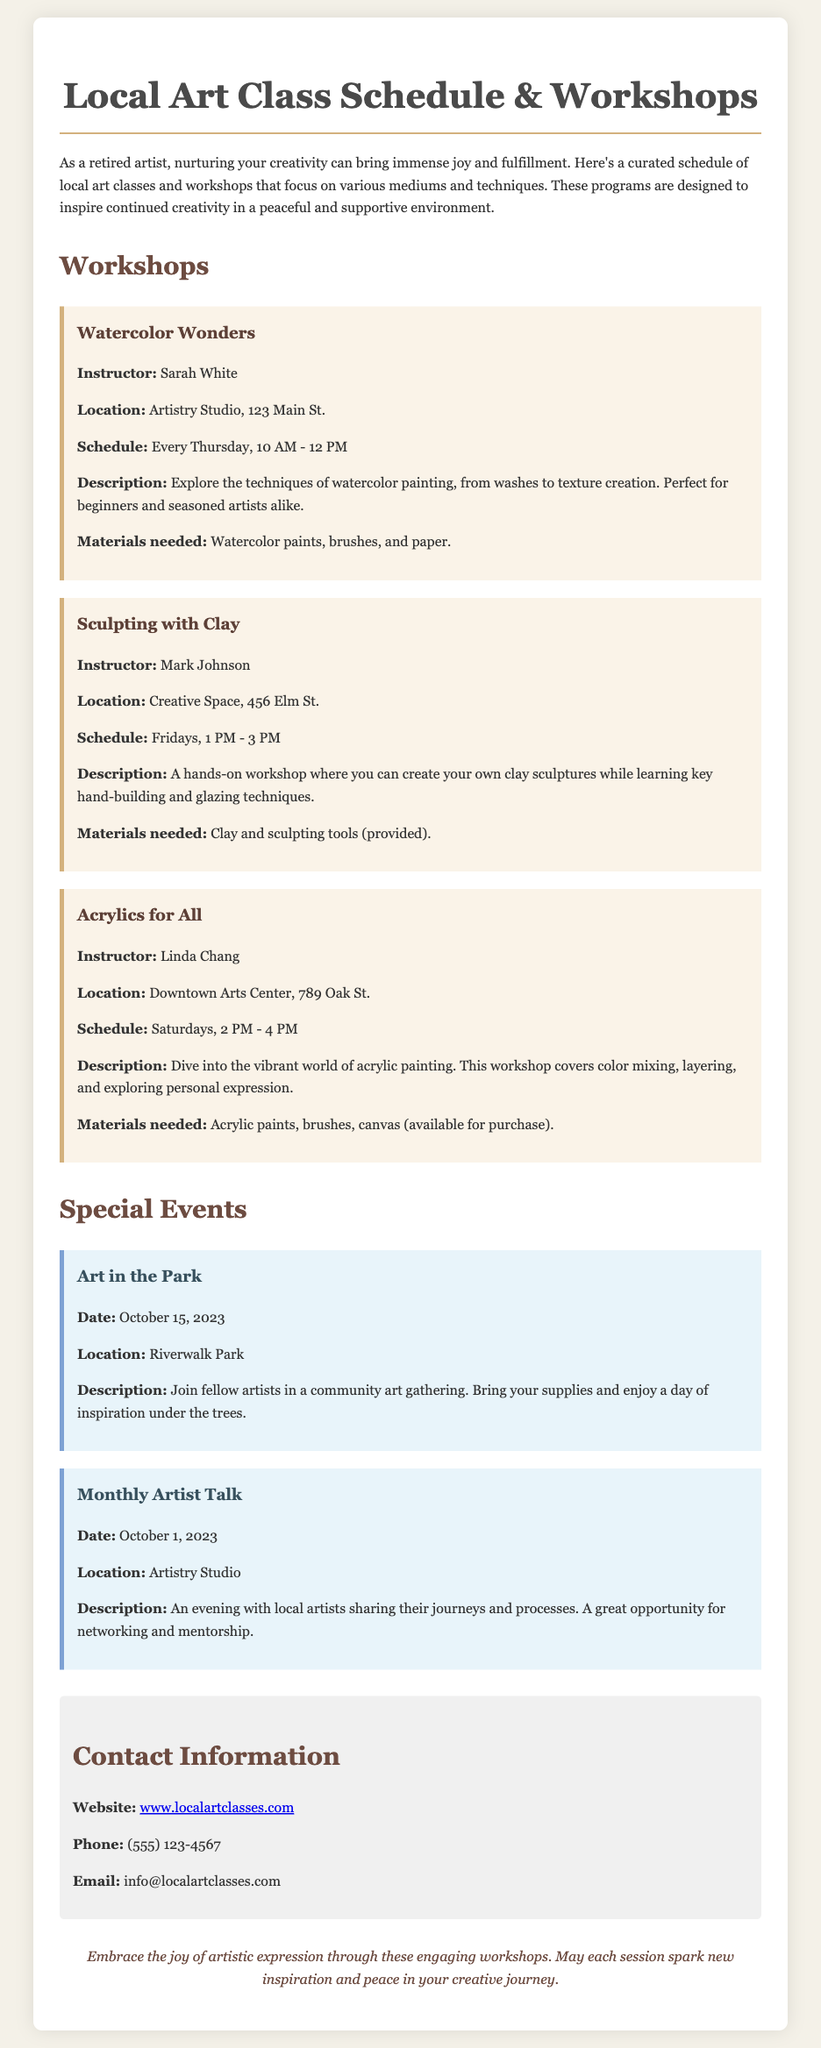What is the name of the workshop focusing on watercolor painting? The document states the workshop is titled "Watercolor Wonders."
Answer: Watercolor Wonders Who is the instructor for the "Sculpting with Clay" workshop? According to the document, Mark Johnson is the instructor.
Answer: Mark Johnson What date is the "Monthly Artist Talk" scheduled for? The document indicates that the "Monthly Artist Talk" is on October 1, 2023.
Answer: October 1, 2023 Where is the "Acrylics for All" workshop held? The document mentions that the "Acrylics for All" workshop is located at Downtown Arts Center, 789 Oak St.
Answer: Downtown Arts Center, 789 Oak St What materials are needed for the "Watercolor Wonders" workshop? The document specifies that watercolor paints, brushes, and paper are needed for this workshop.
Answer: Watercolor paints, brushes, and paper How often does the "Watercolor Wonders" workshop take place? The document states that this workshop occurs every Thursday.
Answer: Every Thursday What is the purpose of the "Art in the Park" event? The document describes the event as a community art gathering for inspiration under the trees.
Answer: Community art gathering for inspiration How can participants contact for more information about the art classes? The document provides a website, phone number, and email for inquiries.
Answer: www.localartclasses.com What color is used for the background of the document? The background color specified in the style is #f4f1e8.
Answer: #f4f1e8 What is the focus of the classes and workshops mentioned in the document? The sentence indicates the focus is to inspire continued creativity in a peaceful and supportive environment.
Answer: Inspire continued creativity 